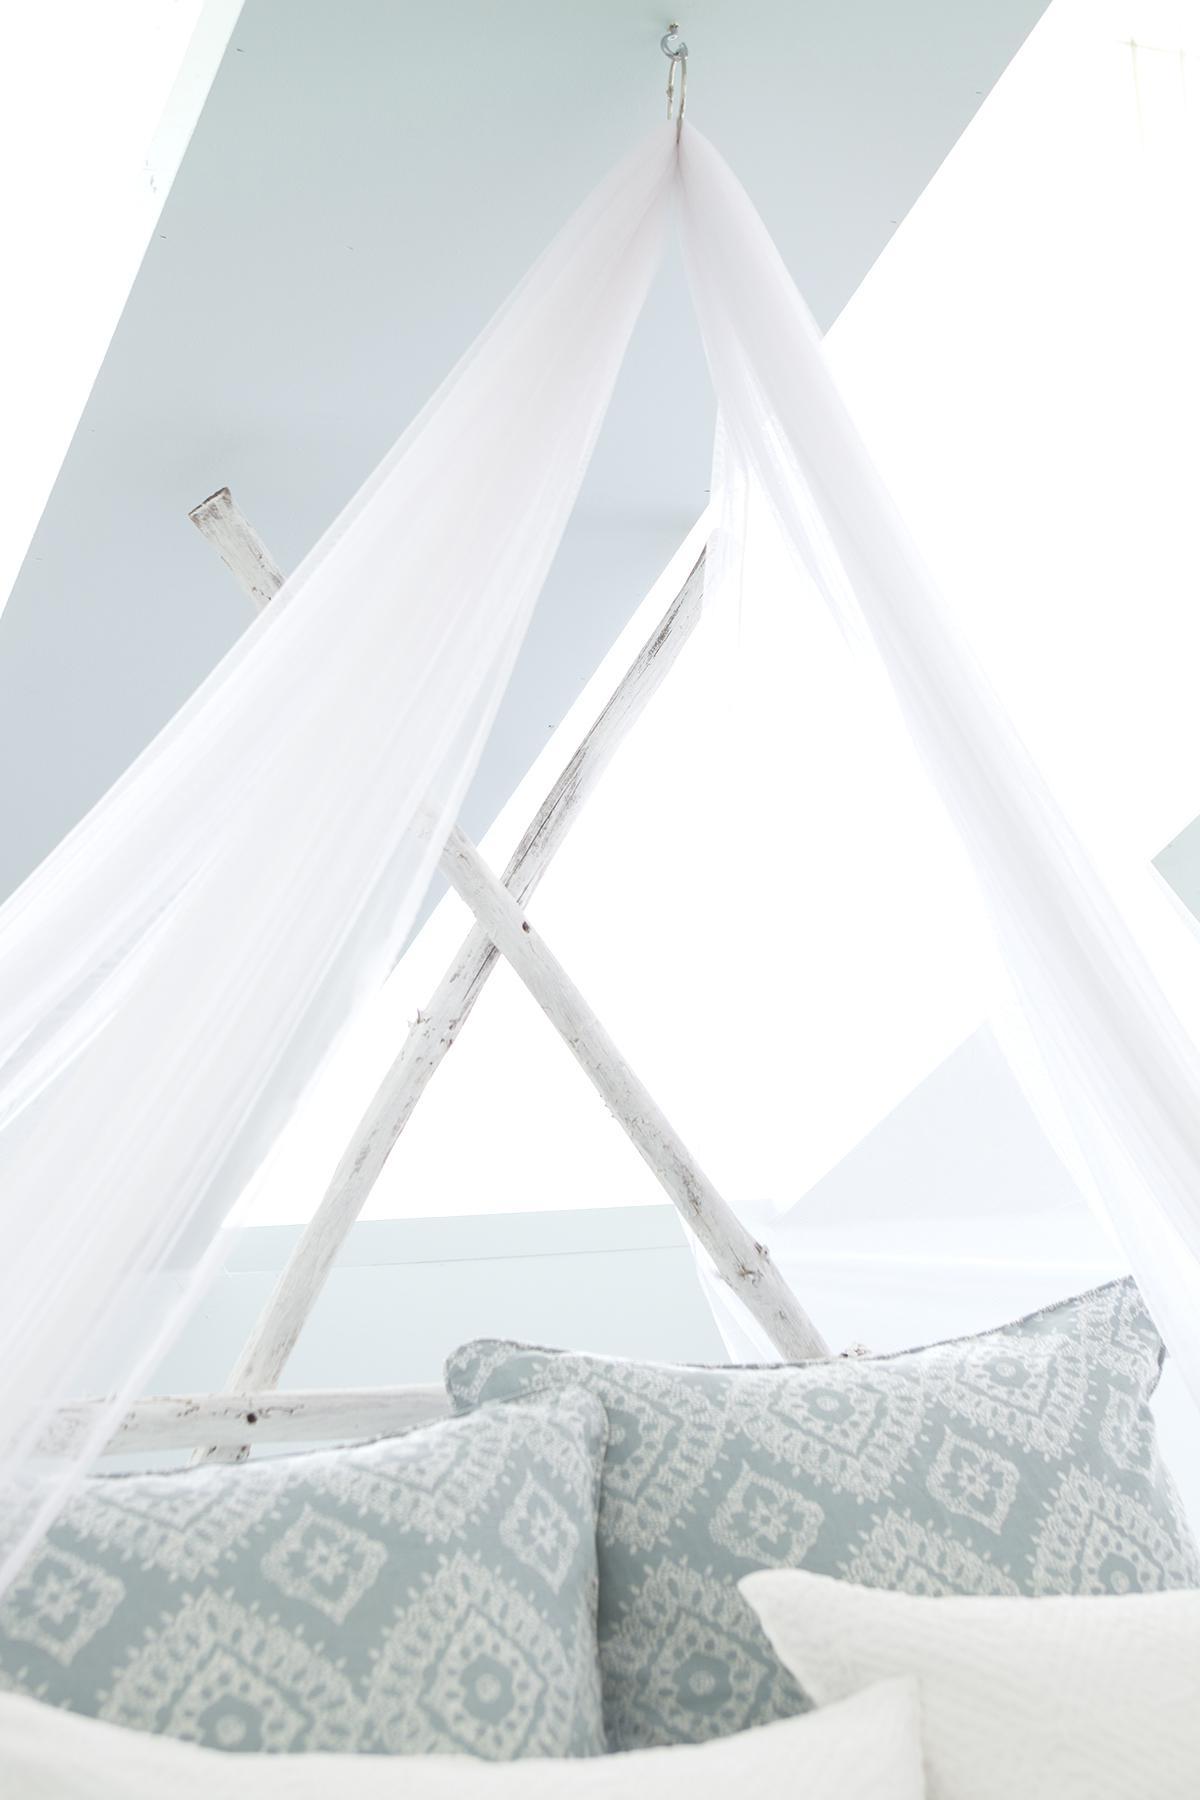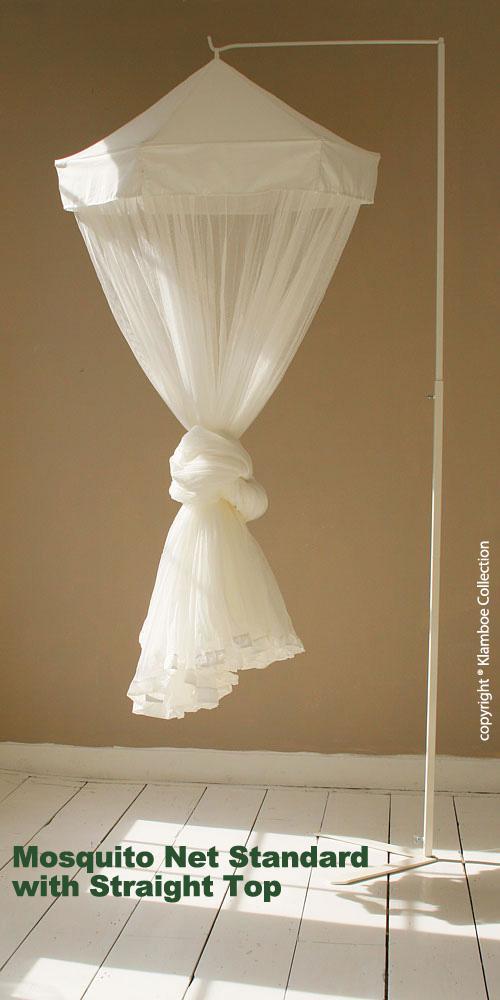The first image is the image on the left, the second image is the image on the right. Examine the images to the left and right. Is the description "In the left image, you can see the entire window; the window top, bottom and both sides are clearly visible." accurate? Answer yes or no. No. The first image is the image on the left, the second image is the image on the right. For the images displayed, is the sentence "There are two circle canopies." factually correct? Answer yes or no. No. 